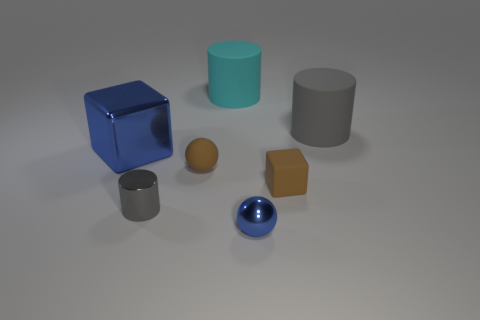Do the blue object to the left of the tiny metal sphere and the tiny blue ball have the same material?
Provide a succinct answer. Yes. Are there any large blue objects?
Provide a short and direct response. Yes. There is a matte object that is to the left of the metallic ball and in front of the large gray matte cylinder; what size is it?
Provide a succinct answer. Small. Is the number of blue objects in front of the big blue metal object greater than the number of small gray objects in front of the small cylinder?
Your response must be concise. Yes. There is another rubber cylinder that is the same color as the small cylinder; what is its size?
Offer a very short reply. Large. The large shiny thing has what color?
Ensure brevity in your answer.  Blue. What color is the cylinder that is both to the left of the big gray thing and behind the big metallic object?
Your answer should be compact. Cyan. There is a matte object that is in front of the ball on the left side of the metal object on the right side of the tiny cylinder; what color is it?
Provide a short and direct response. Brown. What is the color of the other cylinder that is the same size as the gray rubber cylinder?
Provide a short and direct response. Cyan. What shape is the blue metal object that is to the right of the blue thing on the left side of the blue object right of the big metal thing?
Your response must be concise. Sphere. 